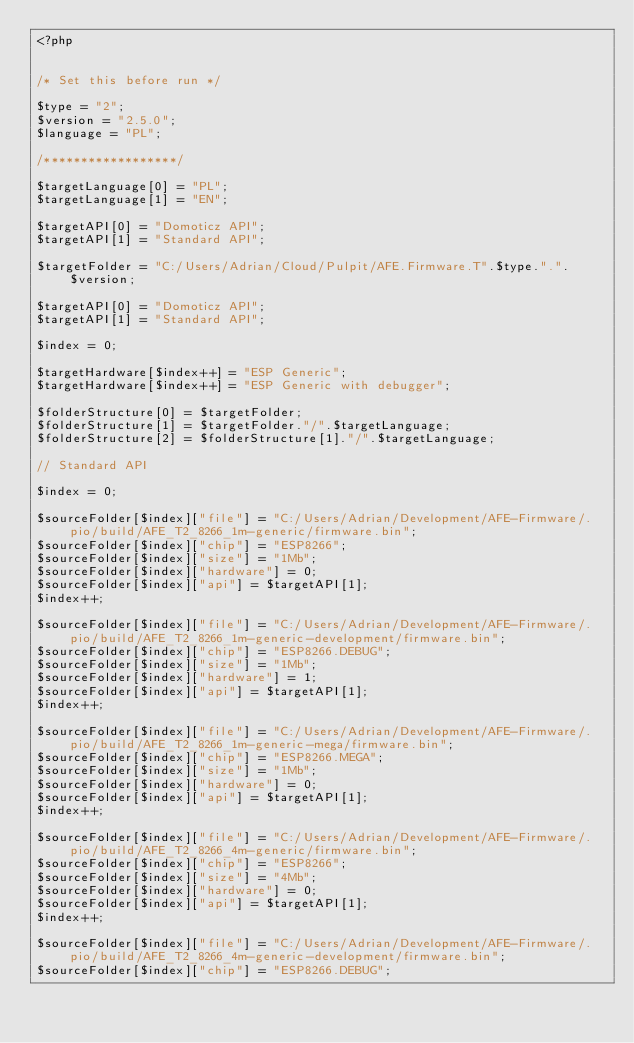<code> <loc_0><loc_0><loc_500><loc_500><_PHP_><?php


/* Set this before run */

$type = "2";
$version = "2.5.0";
$language = "PL";

/******************/

$targetLanguage[0] = "PL";
$targetLanguage[1] = "EN";

$targetAPI[0] = "Domoticz API";
$targetAPI[1] = "Standard API";

$targetFolder = "C:/Users/Adrian/Cloud/Pulpit/AFE.Firmware.T".$type.".".$version;

$targetAPI[0] = "Domoticz API";
$targetAPI[1] = "Standard API";

$index = 0;

$targetHardware[$index++] = "ESP Generic";
$targetHardware[$index++] = "ESP Generic with debugger";

$folderStructure[0] = $targetFolder;
$folderStructure[1] = $targetFolder."/".$targetLanguage;
$folderStructure[2] = $folderStructure[1]."/".$targetLanguage;

// Standard API

$index = 0;

$sourceFolder[$index]["file"] = "C:/Users/Adrian/Development/AFE-Firmware/.pio/build/AFE_T2_8266_1m-generic/firmware.bin";
$sourceFolder[$index]["chip"] = "ESP8266";
$sourceFolder[$index]["size"] = "1Mb";
$sourceFolder[$index]["hardware"] = 0;
$sourceFolder[$index]["api"] = $targetAPI[1];
$index++;

$sourceFolder[$index]["file"] = "C:/Users/Adrian/Development/AFE-Firmware/.pio/build/AFE_T2_8266_1m-generic-development/firmware.bin";
$sourceFolder[$index]["chip"] = "ESP8266.DEBUG";
$sourceFolder[$index]["size"] = "1Mb";
$sourceFolder[$index]["hardware"] = 1;
$sourceFolder[$index]["api"] = $targetAPI[1];
$index++;

$sourceFolder[$index]["file"] = "C:/Users/Adrian/Development/AFE-Firmware/.pio/build/AFE_T2_8266_1m-generic-mega/firmware.bin";
$sourceFolder[$index]["chip"] = "ESP8266.MEGA";
$sourceFolder[$index]["size"] = "1Mb";
$sourceFolder[$index]["hardware"] = 0;
$sourceFolder[$index]["api"] = $targetAPI[1];
$index++;

$sourceFolder[$index]["file"] = "C:/Users/Adrian/Development/AFE-Firmware/.pio/build/AFE_T2_8266_4m-generic/firmware.bin";
$sourceFolder[$index]["chip"] = "ESP8266";
$sourceFolder[$index]["size"] = "4Mb";
$sourceFolder[$index]["hardware"] = 0;
$sourceFolder[$index]["api"] = $targetAPI[1];
$index++;

$sourceFolder[$index]["file"] = "C:/Users/Adrian/Development/AFE-Firmware/.pio/build/AFE_T2_8266_4m-generic-development/firmware.bin";
$sourceFolder[$index]["chip"] = "ESP8266.DEBUG";</code> 